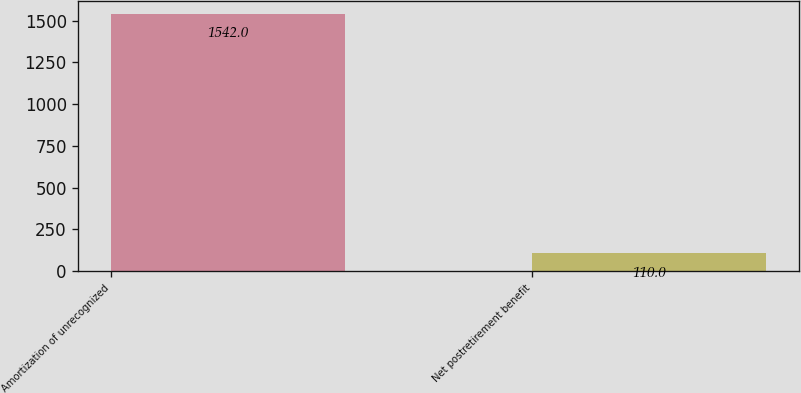Convert chart to OTSL. <chart><loc_0><loc_0><loc_500><loc_500><bar_chart><fcel>Amortization of unrecognized<fcel>Net postretirement benefit<nl><fcel>1542<fcel>110<nl></chart> 